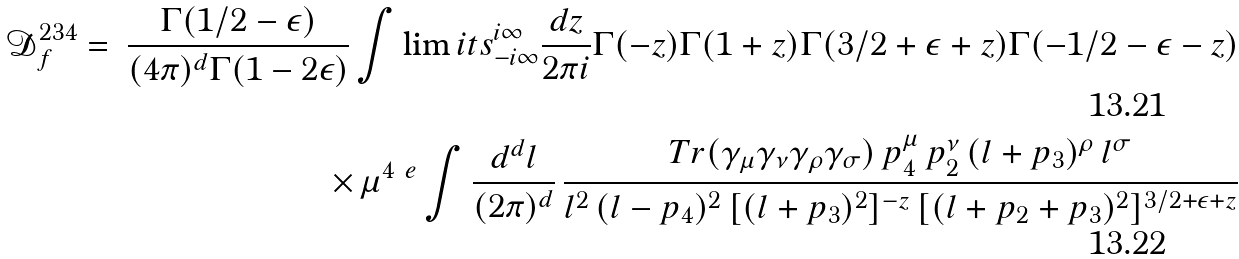Convert formula to latex. <formula><loc_0><loc_0><loc_500><loc_500>\mathcal { D } ^ { 2 3 4 } _ { f } & = & \frac { \Gamma ( 1 / 2 - \epsilon ) } { ( 4 \pi ) ^ { d } \Gamma ( 1 - 2 \epsilon ) } \int \lim i t s _ { - i \infty } ^ { i \infty } \frac { d { z } } { 2 \pi i } \Gamma ( - { z } ) \Gamma ( 1 + { z } ) \Gamma ( 3 / 2 + \epsilon + { z } ) \Gamma ( - 1 / 2 - \epsilon - { z } ) \\ & & \times \, \mu ^ { 4 \ e } \int \frac { d ^ { d } l } { ( 2 \pi ) ^ { d } } \, \frac { T r ( \gamma _ { \mu } \gamma _ { \nu } \gamma _ { \rho } \gamma _ { \sigma } ) \, p _ { 4 } ^ { \mu } \, p _ { 2 } ^ { \nu } \, ( l + p _ { 3 } ) ^ { \rho } \, l ^ { \sigma } } { l ^ { 2 } \, ( l - p _ { 4 } ) ^ { 2 } \, [ ( l + p _ { 3 } ) ^ { 2 } ] ^ { - { z } } \, [ ( l + p _ { 2 } + p _ { 3 } ) ^ { 2 } ] ^ { 3 / 2 + \epsilon + { z } } }</formula> 